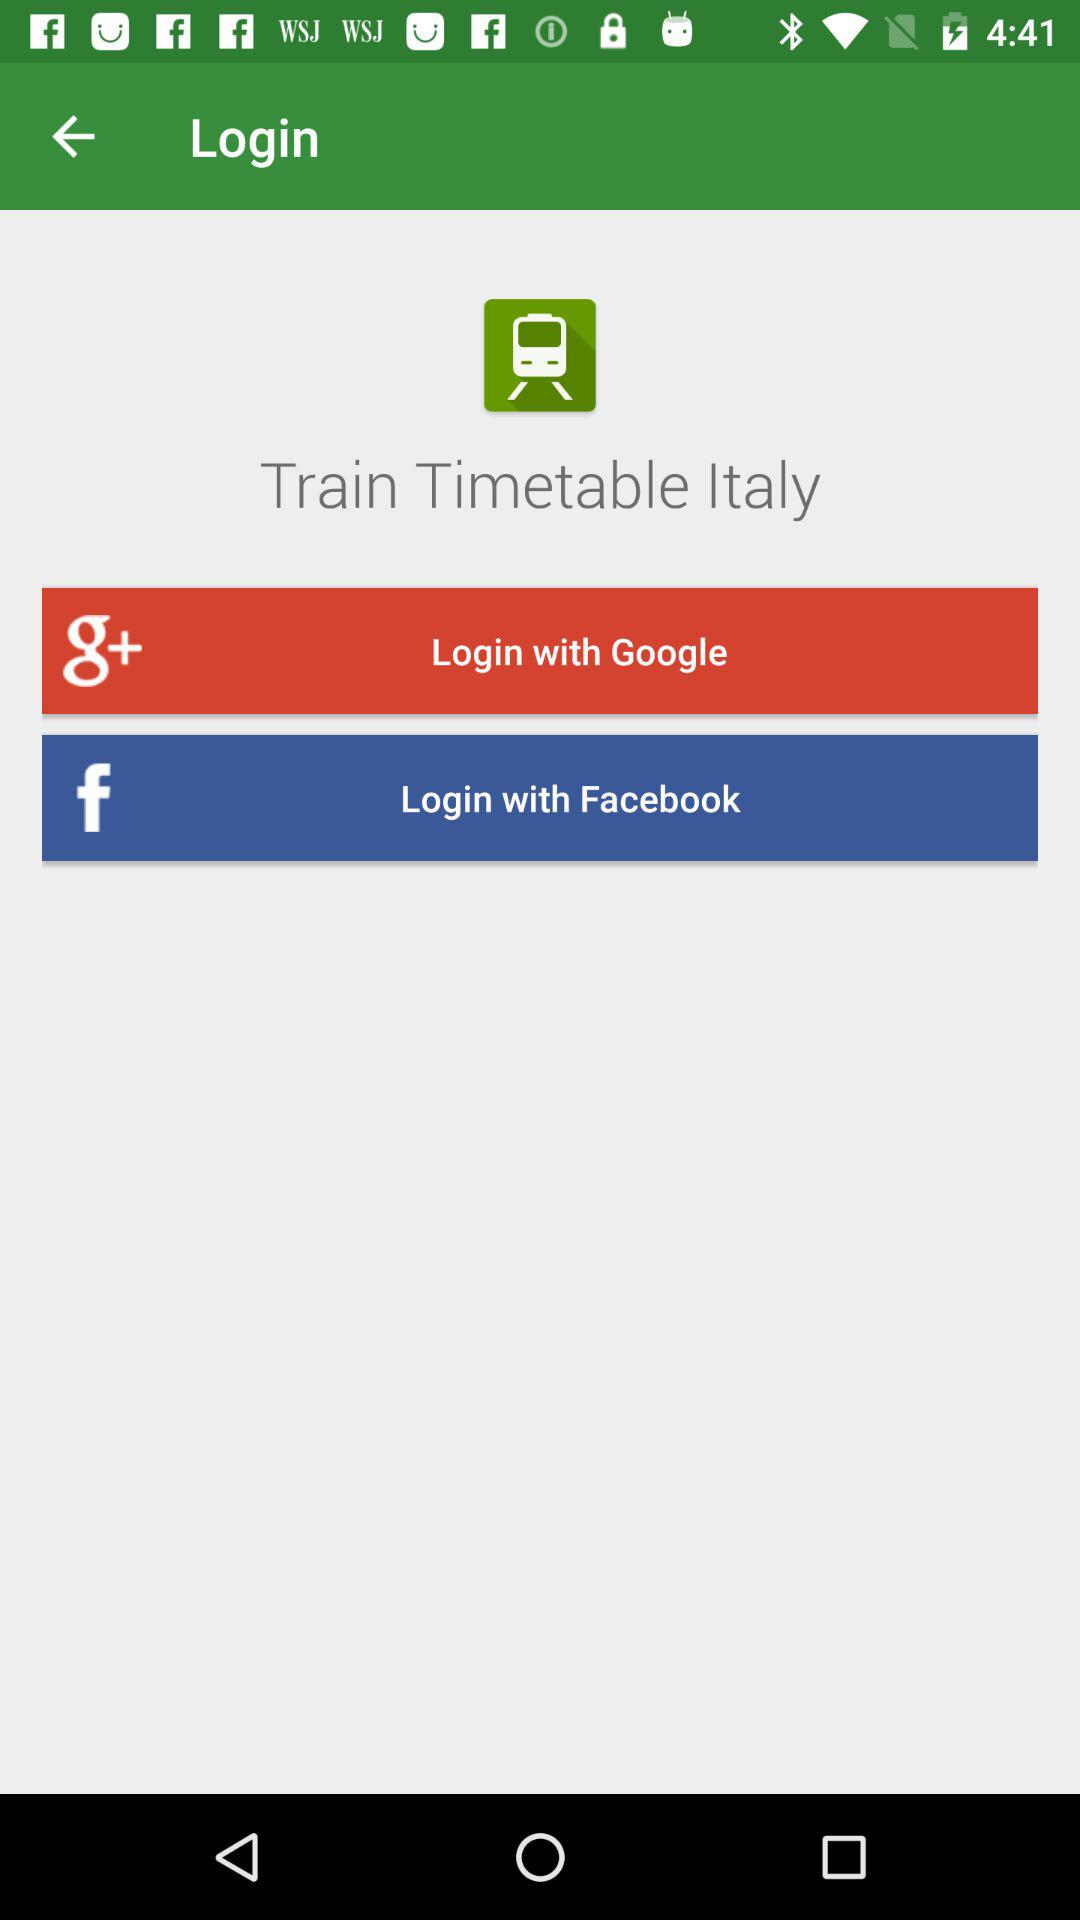Through which application can we log in? You can log in through "Google" and "Facebook". 